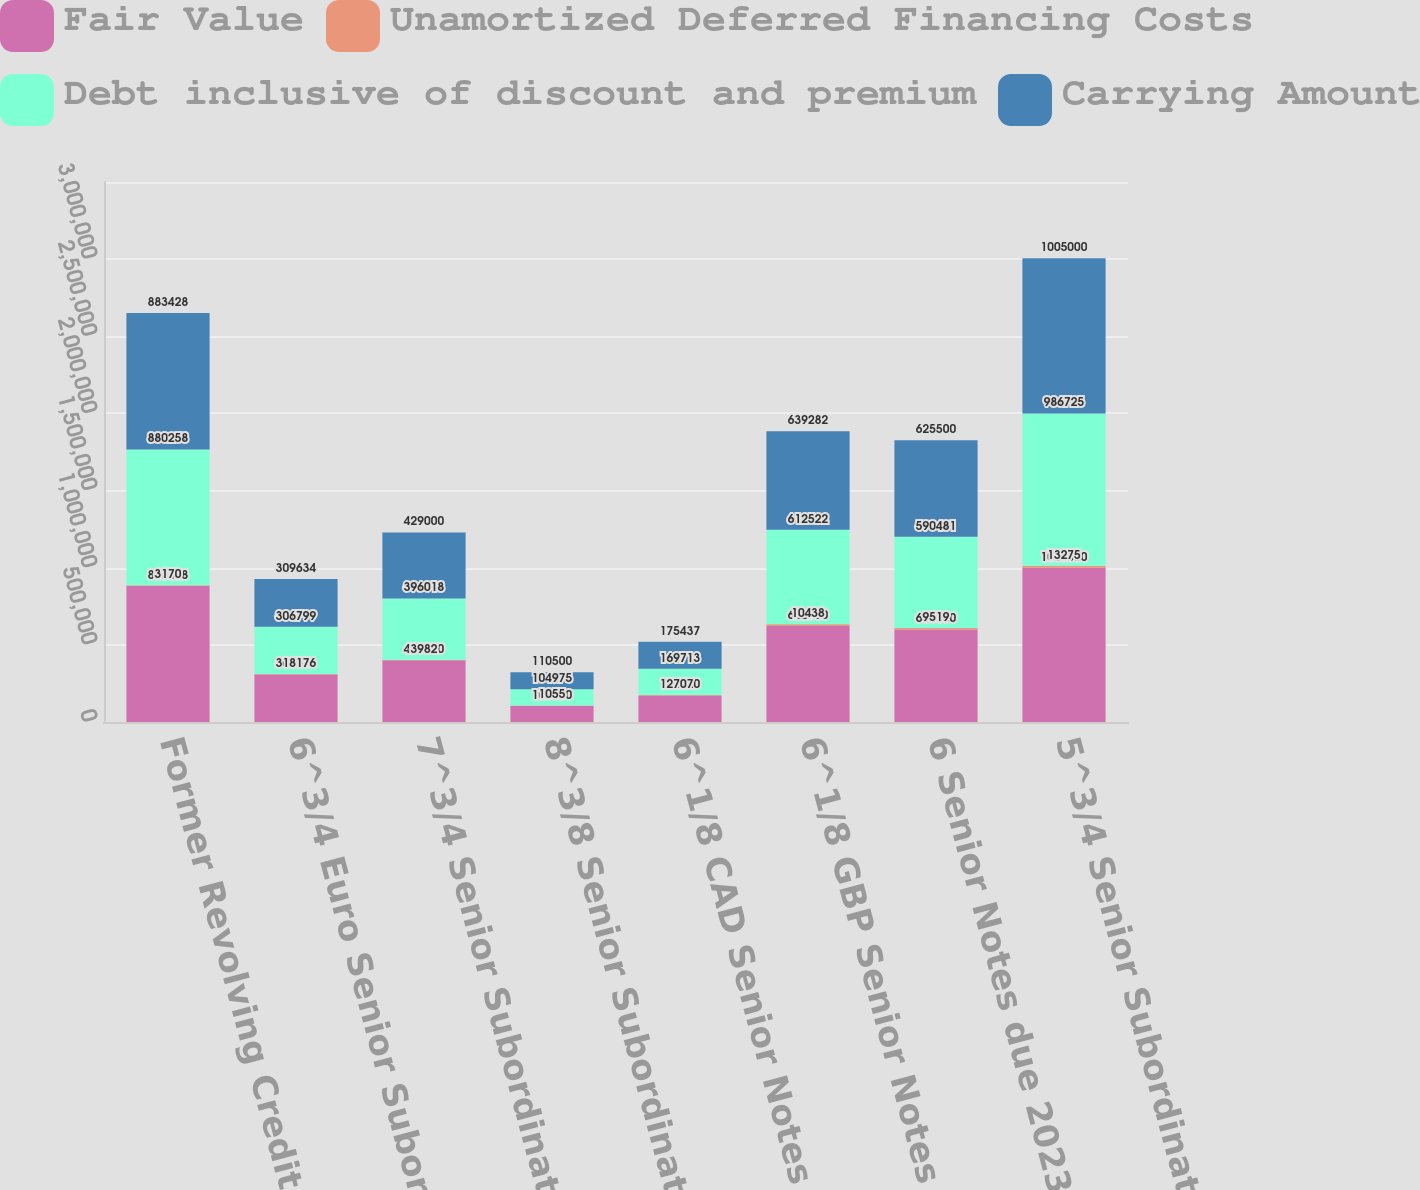Convert chart to OTSL. <chart><loc_0><loc_0><loc_500><loc_500><stacked_bar_chart><ecel><fcel>Former Revolving Credit<fcel>6^3/4 Euro Senior Subordinated<fcel>7^3/4 Senior Subordinated<fcel>8^3/8 Senior Subordinated<fcel>6^1/8 CAD Senior Notes due<fcel>6^1/8 GBP Senior Notes due<fcel>6 Senior Notes due 2023 (the 6<fcel>5^3/4 Senior Subordinated<nl><fcel>Fair Value<fcel>883428<fcel>308616<fcel>400000<fcel>106030<fcel>172420<fcel>622960<fcel>600000<fcel>1e+06<nl><fcel>Unamortized Deferred Financing Costs<fcel>3170<fcel>1817<fcel>3982<fcel>1055<fcel>2707<fcel>10438<fcel>9519<fcel>13275<nl><fcel>Debt inclusive of discount and premium<fcel>880258<fcel>306799<fcel>396018<fcel>104975<fcel>169713<fcel>612522<fcel>590481<fcel>986725<nl><fcel>Carrying Amount<fcel>883428<fcel>309634<fcel>429000<fcel>110500<fcel>175437<fcel>639282<fcel>625500<fcel>1.005e+06<nl></chart> 